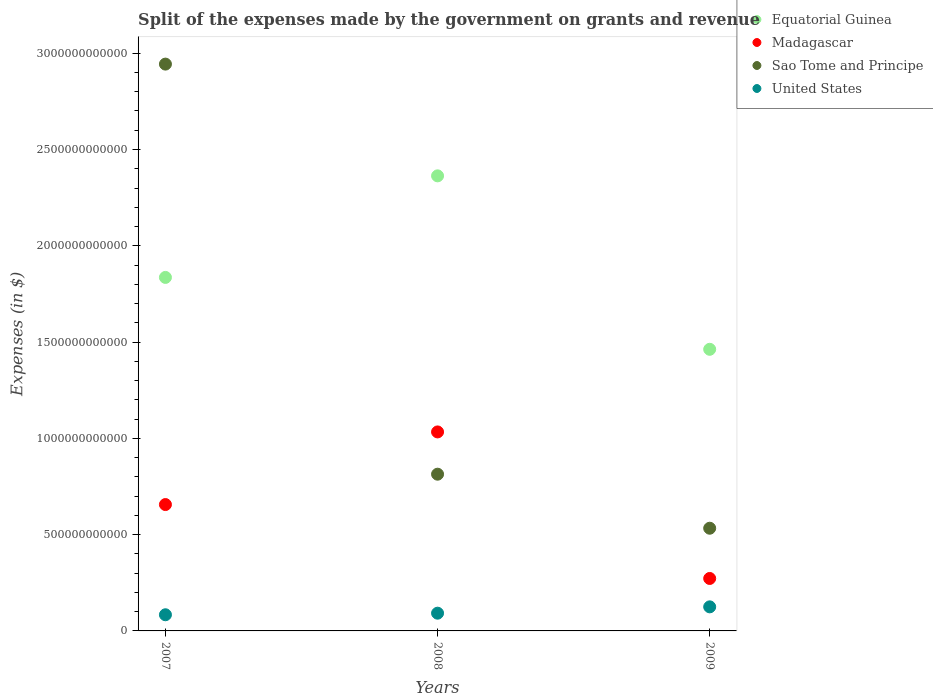How many different coloured dotlines are there?
Your answer should be very brief. 4. What is the expenses made by the government on grants and revenue in United States in 2009?
Keep it short and to the point. 1.25e+11. Across all years, what is the maximum expenses made by the government on grants and revenue in Equatorial Guinea?
Ensure brevity in your answer.  2.36e+12. Across all years, what is the minimum expenses made by the government on grants and revenue in Sao Tome and Principe?
Offer a very short reply. 5.33e+11. In which year was the expenses made by the government on grants and revenue in United States maximum?
Provide a short and direct response. 2009. What is the total expenses made by the government on grants and revenue in United States in the graph?
Your answer should be very brief. 3.01e+11. What is the difference between the expenses made by the government on grants and revenue in Madagascar in 2008 and that in 2009?
Offer a terse response. 7.61e+11. What is the difference between the expenses made by the government on grants and revenue in Equatorial Guinea in 2009 and the expenses made by the government on grants and revenue in Madagascar in 2008?
Ensure brevity in your answer.  4.29e+11. What is the average expenses made by the government on grants and revenue in United States per year?
Your answer should be compact. 1.00e+11. In the year 2009, what is the difference between the expenses made by the government on grants and revenue in United States and expenses made by the government on grants and revenue in Equatorial Guinea?
Provide a short and direct response. -1.34e+12. What is the ratio of the expenses made by the government on grants and revenue in Madagascar in 2008 to that in 2009?
Offer a very short reply. 3.79. What is the difference between the highest and the second highest expenses made by the government on grants and revenue in Sao Tome and Principe?
Provide a succinct answer. 2.13e+12. What is the difference between the highest and the lowest expenses made by the government on grants and revenue in United States?
Your response must be concise. 4.11e+1. In how many years, is the expenses made by the government on grants and revenue in Madagascar greater than the average expenses made by the government on grants and revenue in Madagascar taken over all years?
Your answer should be compact. 2. Is the sum of the expenses made by the government on grants and revenue in Sao Tome and Principe in 2007 and 2009 greater than the maximum expenses made by the government on grants and revenue in Equatorial Guinea across all years?
Give a very brief answer. Yes. Is the expenses made by the government on grants and revenue in Sao Tome and Principe strictly greater than the expenses made by the government on grants and revenue in United States over the years?
Your response must be concise. Yes. Is the expenses made by the government on grants and revenue in Sao Tome and Principe strictly less than the expenses made by the government on grants and revenue in Equatorial Guinea over the years?
Offer a terse response. No. How many dotlines are there?
Offer a very short reply. 4. What is the difference between two consecutive major ticks on the Y-axis?
Your answer should be very brief. 5.00e+11. Does the graph contain any zero values?
Keep it short and to the point. No. What is the title of the graph?
Keep it short and to the point. Split of the expenses made by the government on grants and revenue. Does "Luxembourg" appear as one of the legend labels in the graph?
Your answer should be compact. No. What is the label or title of the Y-axis?
Keep it short and to the point. Expenses (in $). What is the Expenses (in $) of Equatorial Guinea in 2007?
Give a very brief answer. 1.84e+12. What is the Expenses (in $) in Madagascar in 2007?
Your answer should be compact. 6.56e+11. What is the Expenses (in $) in Sao Tome and Principe in 2007?
Keep it short and to the point. 2.94e+12. What is the Expenses (in $) in United States in 2007?
Ensure brevity in your answer.  8.39e+1. What is the Expenses (in $) in Equatorial Guinea in 2008?
Give a very brief answer. 2.36e+12. What is the Expenses (in $) of Madagascar in 2008?
Offer a terse response. 1.03e+12. What is the Expenses (in $) in Sao Tome and Principe in 2008?
Your answer should be compact. 8.14e+11. What is the Expenses (in $) in United States in 2008?
Give a very brief answer. 9.21e+1. What is the Expenses (in $) in Equatorial Guinea in 2009?
Offer a very short reply. 1.46e+12. What is the Expenses (in $) in Madagascar in 2009?
Offer a terse response. 2.72e+11. What is the Expenses (in $) of Sao Tome and Principe in 2009?
Keep it short and to the point. 5.33e+11. What is the Expenses (in $) of United States in 2009?
Your answer should be compact. 1.25e+11. Across all years, what is the maximum Expenses (in $) of Equatorial Guinea?
Your response must be concise. 2.36e+12. Across all years, what is the maximum Expenses (in $) of Madagascar?
Provide a succinct answer. 1.03e+12. Across all years, what is the maximum Expenses (in $) in Sao Tome and Principe?
Keep it short and to the point. 2.94e+12. Across all years, what is the maximum Expenses (in $) of United States?
Offer a terse response. 1.25e+11. Across all years, what is the minimum Expenses (in $) in Equatorial Guinea?
Your response must be concise. 1.46e+12. Across all years, what is the minimum Expenses (in $) in Madagascar?
Your response must be concise. 2.72e+11. Across all years, what is the minimum Expenses (in $) of Sao Tome and Principe?
Give a very brief answer. 5.33e+11. Across all years, what is the minimum Expenses (in $) of United States?
Keep it short and to the point. 8.39e+1. What is the total Expenses (in $) in Equatorial Guinea in the graph?
Your answer should be compact. 5.66e+12. What is the total Expenses (in $) of Madagascar in the graph?
Offer a terse response. 1.96e+12. What is the total Expenses (in $) of Sao Tome and Principe in the graph?
Keep it short and to the point. 4.29e+12. What is the total Expenses (in $) of United States in the graph?
Ensure brevity in your answer.  3.01e+11. What is the difference between the Expenses (in $) in Equatorial Guinea in 2007 and that in 2008?
Your response must be concise. -5.27e+11. What is the difference between the Expenses (in $) of Madagascar in 2007 and that in 2008?
Ensure brevity in your answer.  -3.77e+11. What is the difference between the Expenses (in $) in Sao Tome and Principe in 2007 and that in 2008?
Keep it short and to the point. 2.13e+12. What is the difference between the Expenses (in $) of United States in 2007 and that in 2008?
Offer a very short reply. -8.20e+09. What is the difference between the Expenses (in $) in Equatorial Guinea in 2007 and that in 2009?
Your answer should be very brief. 3.73e+11. What is the difference between the Expenses (in $) of Madagascar in 2007 and that in 2009?
Provide a succinct answer. 3.84e+11. What is the difference between the Expenses (in $) of Sao Tome and Principe in 2007 and that in 2009?
Your response must be concise. 2.41e+12. What is the difference between the Expenses (in $) of United States in 2007 and that in 2009?
Make the answer very short. -4.11e+1. What is the difference between the Expenses (in $) of Equatorial Guinea in 2008 and that in 2009?
Your answer should be compact. 9.01e+11. What is the difference between the Expenses (in $) in Madagascar in 2008 and that in 2009?
Make the answer very short. 7.61e+11. What is the difference between the Expenses (in $) in Sao Tome and Principe in 2008 and that in 2009?
Make the answer very short. 2.81e+11. What is the difference between the Expenses (in $) in United States in 2008 and that in 2009?
Keep it short and to the point. -3.29e+1. What is the difference between the Expenses (in $) in Equatorial Guinea in 2007 and the Expenses (in $) in Madagascar in 2008?
Ensure brevity in your answer.  8.02e+11. What is the difference between the Expenses (in $) of Equatorial Guinea in 2007 and the Expenses (in $) of Sao Tome and Principe in 2008?
Provide a succinct answer. 1.02e+12. What is the difference between the Expenses (in $) of Equatorial Guinea in 2007 and the Expenses (in $) of United States in 2008?
Provide a short and direct response. 1.74e+12. What is the difference between the Expenses (in $) in Madagascar in 2007 and the Expenses (in $) in Sao Tome and Principe in 2008?
Offer a very short reply. -1.58e+11. What is the difference between the Expenses (in $) in Madagascar in 2007 and the Expenses (in $) in United States in 2008?
Give a very brief answer. 5.64e+11. What is the difference between the Expenses (in $) of Sao Tome and Principe in 2007 and the Expenses (in $) of United States in 2008?
Provide a short and direct response. 2.85e+12. What is the difference between the Expenses (in $) in Equatorial Guinea in 2007 and the Expenses (in $) in Madagascar in 2009?
Offer a terse response. 1.56e+12. What is the difference between the Expenses (in $) in Equatorial Guinea in 2007 and the Expenses (in $) in Sao Tome and Principe in 2009?
Provide a short and direct response. 1.30e+12. What is the difference between the Expenses (in $) in Equatorial Guinea in 2007 and the Expenses (in $) in United States in 2009?
Your answer should be compact. 1.71e+12. What is the difference between the Expenses (in $) in Madagascar in 2007 and the Expenses (in $) in Sao Tome and Principe in 2009?
Provide a short and direct response. 1.23e+11. What is the difference between the Expenses (in $) in Madagascar in 2007 and the Expenses (in $) in United States in 2009?
Give a very brief answer. 5.31e+11. What is the difference between the Expenses (in $) in Sao Tome and Principe in 2007 and the Expenses (in $) in United States in 2009?
Offer a terse response. 2.82e+12. What is the difference between the Expenses (in $) in Equatorial Guinea in 2008 and the Expenses (in $) in Madagascar in 2009?
Ensure brevity in your answer.  2.09e+12. What is the difference between the Expenses (in $) in Equatorial Guinea in 2008 and the Expenses (in $) in Sao Tome and Principe in 2009?
Offer a terse response. 1.83e+12. What is the difference between the Expenses (in $) in Equatorial Guinea in 2008 and the Expenses (in $) in United States in 2009?
Offer a very short reply. 2.24e+12. What is the difference between the Expenses (in $) of Madagascar in 2008 and the Expenses (in $) of Sao Tome and Principe in 2009?
Your answer should be compact. 5.00e+11. What is the difference between the Expenses (in $) of Madagascar in 2008 and the Expenses (in $) of United States in 2009?
Keep it short and to the point. 9.08e+11. What is the difference between the Expenses (in $) in Sao Tome and Principe in 2008 and the Expenses (in $) in United States in 2009?
Make the answer very short. 6.89e+11. What is the average Expenses (in $) of Equatorial Guinea per year?
Keep it short and to the point. 1.89e+12. What is the average Expenses (in $) in Madagascar per year?
Provide a succinct answer. 6.54e+11. What is the average Expenses (in $) in Sao Tome and Principe per year?
Provide a short and direct response. 1.43e+12. What is the average Expenses (in $) of United States per year?
Your answer should be very brief. 1.00e+11. In the year 2007, what is the difference between the Expenses (in $) in Equatorial Guinea and Expenses (in $) in Madagascar?
Provide a succinct answer. 1.18e+12. In the year 2007, what is the difference between the Expenses (in $) of Equatorial Guinea and Expenses (in $) of Sao Tome and Principe?
Give a very brief answer. -1.11e+12. In the year 2007, what is the difference between the Expenses (in $) of Equatorial Guinea and Expenses (in $) of United States?
Offer a terse response. 1.75e+12. In the year 2007, what is the difference between the Expenses (in $) of Madagascar and Expenses (in $) of Sao Tome and Principe?
Your answer should be very brief. -2.29e+12. In the year 2007, what is the difference between the Expenses (in $) of Madagascar and Expenses (in $) of United States?
Give a very brief answer. 5.72e+11. In the year 2007, what is the difference between the Expenses (in $) in Sao Tome and Principe and Expenses (in $) in United States?
Provide a short and direct response. 2.86e+12. In the year 2008, what is the difference between the Expenses (in $) of Equatorial Guinea and Expenses (in $) of Madagascar?
Offer a very short reply. 1.33e+12. In the year 2008, what is the difference between the Expenses (in $) in Equatorial Guinea and Expenses (in $) in Sao Tome and Principe?
Your answer should be compact. 1.55e+12. In the year 2008, what is the difference between the Expenses (in $) of Equatorial Guinea and Expenses (in $) of United States?
Offer a terse response. 2.27e+12. In the year 2008, what is the difference between the Expenses (in $) in Madagascar and Expenses (in $) in Sao Tome and Principe?
Make the answer very short. 2.19e+11. In the year 2008, what is the difference between the Expenses (in $) in Madagascar and Expenses (in $) in United States?
Make the answer very short. 9.41e+11. In the year 2008, what is the difference between the Expenses (in $) in Sao Tome and Principe and Expenses (in $) in United States?
Your response must be concise. 7.22e+11. In the year 2009, what is the difference between the Expenses (in $) in Equatorial Guinea and Expenses (in $) in Madagascar?
Provide a succinct answer. 1.19e+12. In the year 2009, what is the difference between the Expenses (in $) of Equatorial Guinea and Expenses (in $) of Sao Tome and Principe?
Provide a short and direct response. 9.29e+11. In the year 2009, what is the difference between the Expenses (in $) of Equatorial Guinea and Expenses (in $) of United States?
Offer a very short reply. 1.34e+12. In the year 2009, what is the difference between the Expenses (in $) of Madagascar and Expenses (in $) of Sao Tome and Principe?
Keep it short and to the point. -2.61e+11. In the year 2009, what is the difference between the Expenses (in $) of Madagascar and Expenses (in $) of United States?
Provide a succinct answer. 1.47e+11. In the year 2009, what is the difference between the Expenses (in $) of Sao Tome and Principe and Expenses (in $) of United States?
Your answer should be very brief. 4.08e+11. What is the ratio of the Expenses (in $) of Equatorial Guinea in 2007 to that in 2008?
Provide a succinct answer. 0.78. What is the ratio of the Expenses (in $) of Madagascar in 2007 to that in 2008?
Offer a very short reply. 0.64. What is the ratio of the Expenses (in $) of Sao Tome and Principe in 2007 to that in 2008?
Your answer should be compact. 3.62. What is the ratio of the Expenses (in $) of United States in 2007 to that in 2008?
Your answer should be very brief. 0.91. What is the ratio of the Expenses (in $) of Equatorial Guinea in 2007 to that in 2009?
Offer a very short reply. 1.26. What is the ratio of the Expenses (in $) in Madagascar in 2007 to that in 2009?
Offer a terse response. 2.41. What is the ratio of the Expenses (in $) in Sao Tome and Principe in 2007 to that in 2009?
Offer a very short reply. 5.52. What is the ratio of the Expenses (in $) in United States in 2007 to that in 2009?
Make the answer very short. 0.67. What is the ratio of the Expenses (in $) in Equatorial Guinea in 2008 to that in 2009?
Provide a succinct answer. 1.62. What is the ratio of the Expenses (in $) in Madagascar in 2008 to that in 2009?
Offer a very short reply. 3.79. What is the ratio of the Expenses (in $) of Sao Tome and Principe in 2008 to that in 2009?
Your response must be concise. 1.53. What is the ratio of the Expenses (in $) in United States in 2008 to that in 2009?
Give a very brief answer. 0.74. What is the difference between the highest and the second highest Expenses (in $) of Equatorial Guinea?
Keep it short and to the point. 5.27e+11. What is the difference between the highest and the second highest Expenses (in $) of Madagascar?
Your answer should be very brief. 3.77e+11. What is the difference between the highest and the second highest Expenses (in $) of Sao Tome and Principe?
Offer a very short reply. 2.13e+12. What is the difference between the highest and the second highest Expenses (in $) in United States?
Provide a short and direct response. 3.29e+1. What is the difference between the highest and the lowest Expenses (in $) in Equatorial Guinea?
Make the answer very short. 9.01e+11. What is the difference between the highest and the lowest Expenses (in $) in Madagascar?
Provide a short and direct response. 7.61e+11. What is the difference between the highest and the lowest Expenses (in $) in Sao Tome and Principe?
Your answer should be compact. 2.41e+12. What is the difference between the highest and the lowest Expenses (in $) in United States?
Your answer should be compact. 4.11e+1. 